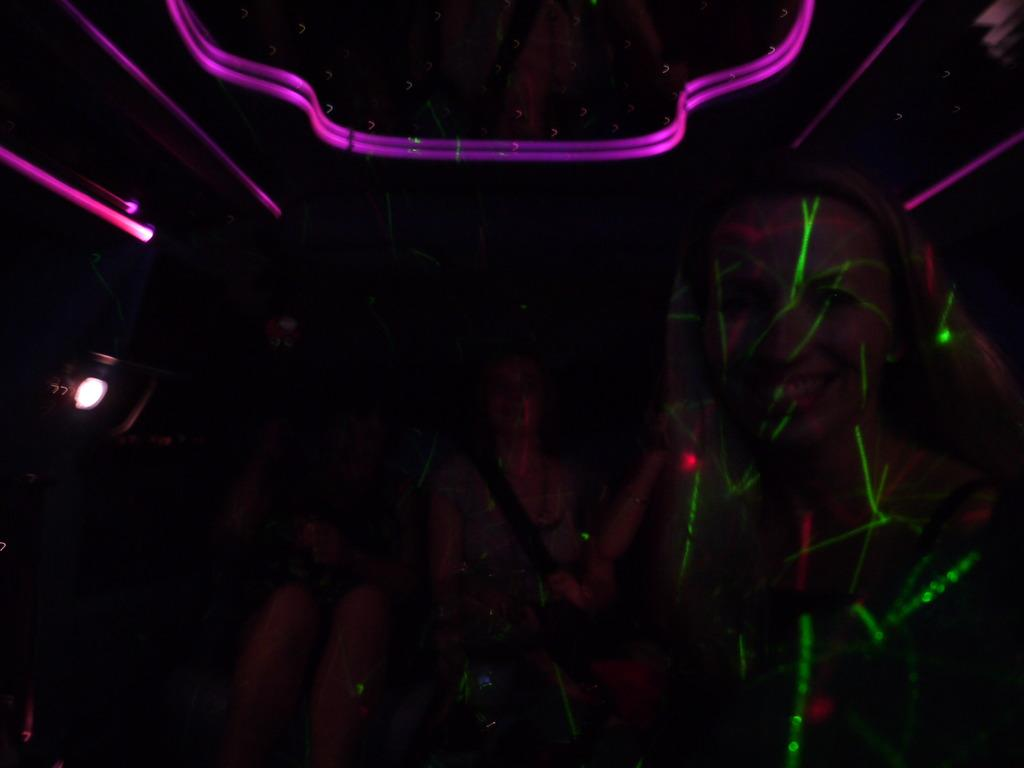What is the lighting condition in the image? The image was taken in a dark environment. Can you identify any subjects in the image? Yes, there are people visible in the image. Where are the lights located in the image? The lights are at the top of the image. What type of pie is being served to the people in the image? There is no pie present in the image; it was taken in a dark environment with people and lights. 